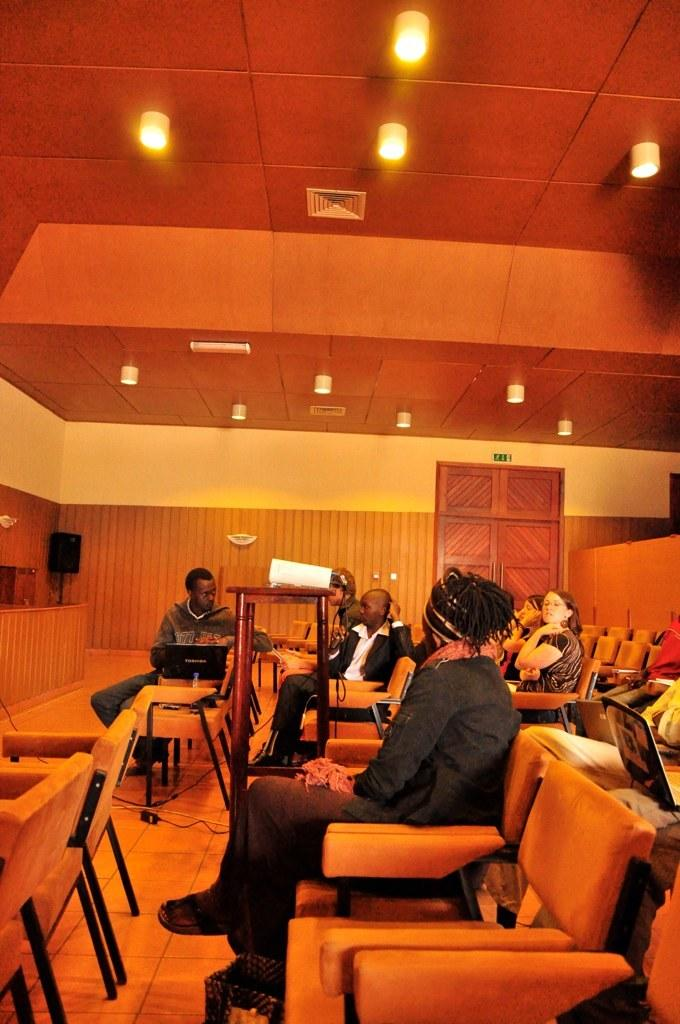What are the people in the image doing? The people in the image are sitting on chairs. What electronic device is on the table in the image? There is a laptop on a table in the image. What can be seen at the top of the image? There are lightings visible at the top of the image. What is used for amplifying sound in the image? There is a speaker on a stand in the image. What statement can be made about the liquid in the image? There is no liquid present in the image. 